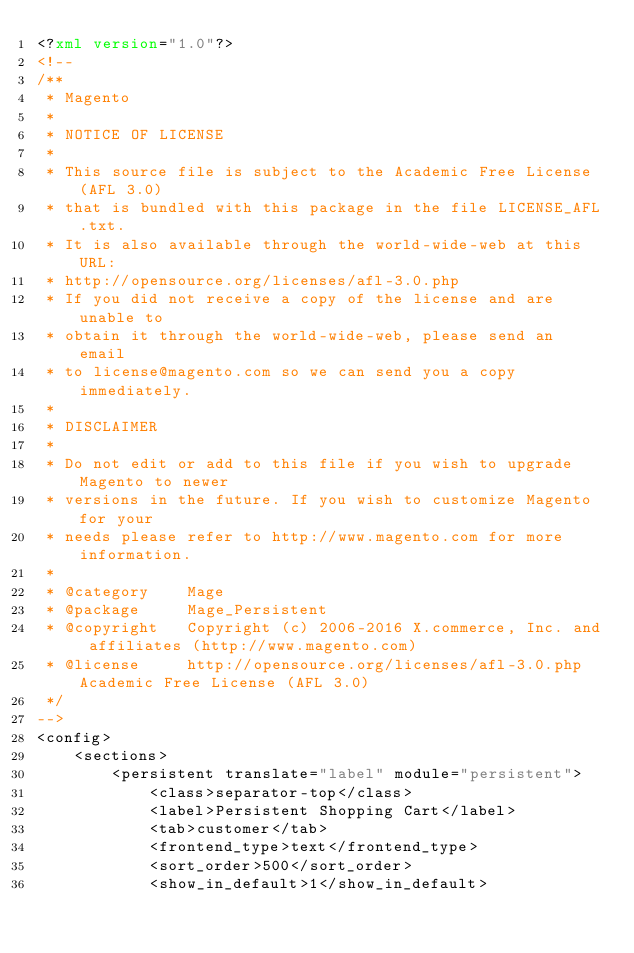Convert code to text. <code><loc_0><loc_0><loc_500><loc_500><_XML_><?xml version="1.0"?>
<!--
/**
 * Magento
 *
 * NOTICE OF LICENSE
 *
 * This source file is subject to the Academic Free License (AFL 3.0)
 * that is bundled with this package in the file LICENSE_AFL.txt.
 * It is also available through the world-wide-web at this URL:
 * http://opensource.org/licenses/afl-3.0.php
 * If you did not receive a copy of the license and are unable to
 * obtain it through the world-wide-web, please send an email
 * to license@magento.com so we can send you a copy immediately.
 *
 * DISCLAIMER
 *
 * Do not edit or add to this file if you wish to upgrade Magento to newer
 * versions in the future. If you wish to customize Magento for your
 * needs please refer to http://www.magento.com for more information.
 *
 * @category    Mage
 * @package     Mage_Persistent
 * @copyright   Copyright (c) 2006-2016 X.commerce, Inc. and affiliates (http://www.magento.com)
 * @license     http://opensource.org/licenses/afl-3.0.php  Academic Free License (AFL 3.0)
 */
-->
<config>
    <sections>
        <persistent translate="label" module="persistent">
            <class>separator-top</class>
            <label>Persistent Shopping Cart</label>
            <tab>customer</tab>
            <frontend_type>text</frontend_type>
            <sort_order>500</sort_order>
            <show_in_default>1</show_in_default></code> 